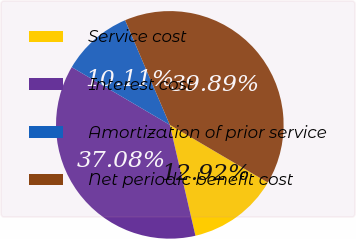Convert chart to OTSL. <chart><loc_0><loc_0><loc_500><loc_500><pie_chart><fcel>Service cost<fcel>Interest cost<fcel>Amortization of prior service<fcel>Net periodic benefit cost<nl><fcel>12.92%<fcel>37.08%<fcel>10.11%<fcel>39.89%<nl></chart> 